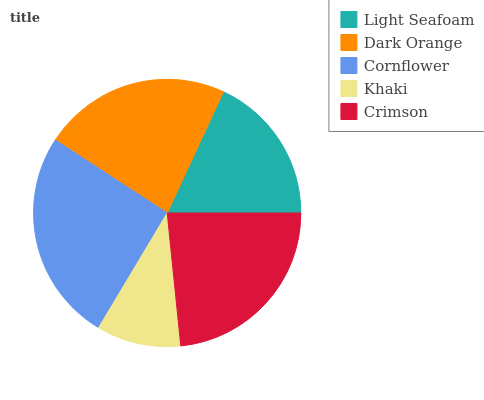Is Khaki the minimum?
Answer yes or no. Yes. Is Cornflower the maximum?
Answer yes or no. Yes. Is Dark Orange the minimum?
Answer yes or no. No. Is Dark Orange the maximum?
Answer yes or no. No. Is Dark Orange greater than Light Seafoam?
Answer yes or no. Yes. Is Light Seafoam less than Dark Orange?
Answer yes or no. Yes. Is Light Seafoam greater than Dark Orange?
Answer yes or no. No. Is Dark Orange less than Light Seafoam?
Answer yes or no. No. Is Dark Orange the high median?
Answer yes or no. Yes. Is Dark Orange the low median?
Answer yes or no. Yes. Is Crimson the high median?
Answer yes or no. No. Is Cornflower the low median?
Answer yes or no. No. 